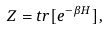Convert formula to latex. <formula><loc_0><loc_0><loc_500><loc_500>Z = t r [ e ^ { - \beta H } ] ,</formula> 